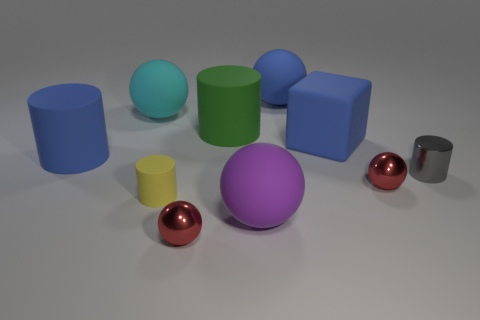How many red spheres must be subtracted to get 1 red spheres? 1 Subtract all blocks. How many objects are left? 9 Subtract 2 cylinders. How many cylinders are left? 2 Subtract all red balls. Subtract all green blocks. How many balls are left? 3 Subtract all gray balls. How many green cylinders are left? 1 Subtract all big green cylinders. Subtract all tiny purple matte cylinders. How many objects are left? 9 Add 7 tiny gray cylinders. How many tiny gray cylinders are left? 8 Add 8 red metal spheres. How many red metal spheres exist? 10 Subtract all yellow cylinders. How many cylinders are left? 3 Subtract all big cyan rubber spheres. How many spheres are left? 4 